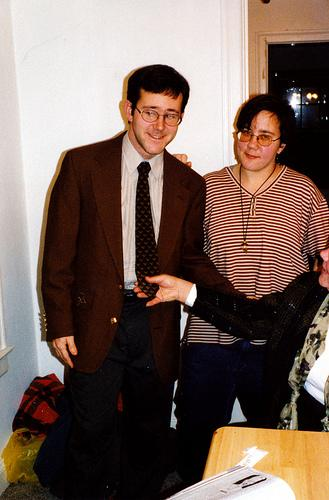Mention the most eye-catching elements in the image. A man in a brown coat with black hair and glasses stands near a woman in a striped shirt and glasses, who has her hand on his shoulder. Explain the primary focus of the image in one sentence. A man with glasses, a brown coat, and black hair is near a woman wearing a striped shirt and glasses. Describe the main subjects and their relationship to each other in the image. The image features a man wearing a brown coat, black hair and glasses, and a woman in a striped shirt and glasses, who seems to be emotionally connected to him as she places a hand on his shoulder. Write a brief description of the image as if introducing it in a movie scene. As the camera focuses, our eyes are drawn to a bespectacled man in a brown coat with black hair, standing somewhat pensively beside a woman in a striped shirt and glasses, her hand on his shoulder as if offering support. Describe the scene as if it is a painting in an art gallery. Here we see a portrait of a man with black hair adorned in a brown coat, with glasses that frame his face. Beside him, a woman wearing a striped shirt and her own pair of glasses gently touches his shoulder – a subtle moment captured in time. Give a casual overview of the primary subjects and action happening in the image. A dude's wearing glasses and a brown coat, and has black hair. There's a woman with glasses and a striped shirt, touching the man's shoulder. Briefly summarize the appearance of the two people in the image. Man: black hair, glasses, brown coat. Woman: glasses, striped shirt, chain necklace. Narrate the image as if it was a scene from a novel. In the dimly lit room, a man with black hair and bespectacled eyes stood wearing a brown coat. A woman in a striped shirt gently placed her hand on his shoulder, her own glasses reflecting the sparse light. Write an informal description of the scene as if you were texting a friend about it. Hey, there's this pic of a guy in a brown coat & glasses with black hair, and a woman with glasses & a striped shirt touching his shoulder. Pretty cool! Highlight the main fashion elements in the image. The fashion-forward man dons a stylish brown coat, black-rimmed glasses, and a black and brown tie, while the woman complements him with a striped shirt, trendy glasses, and a chain around her neck. 